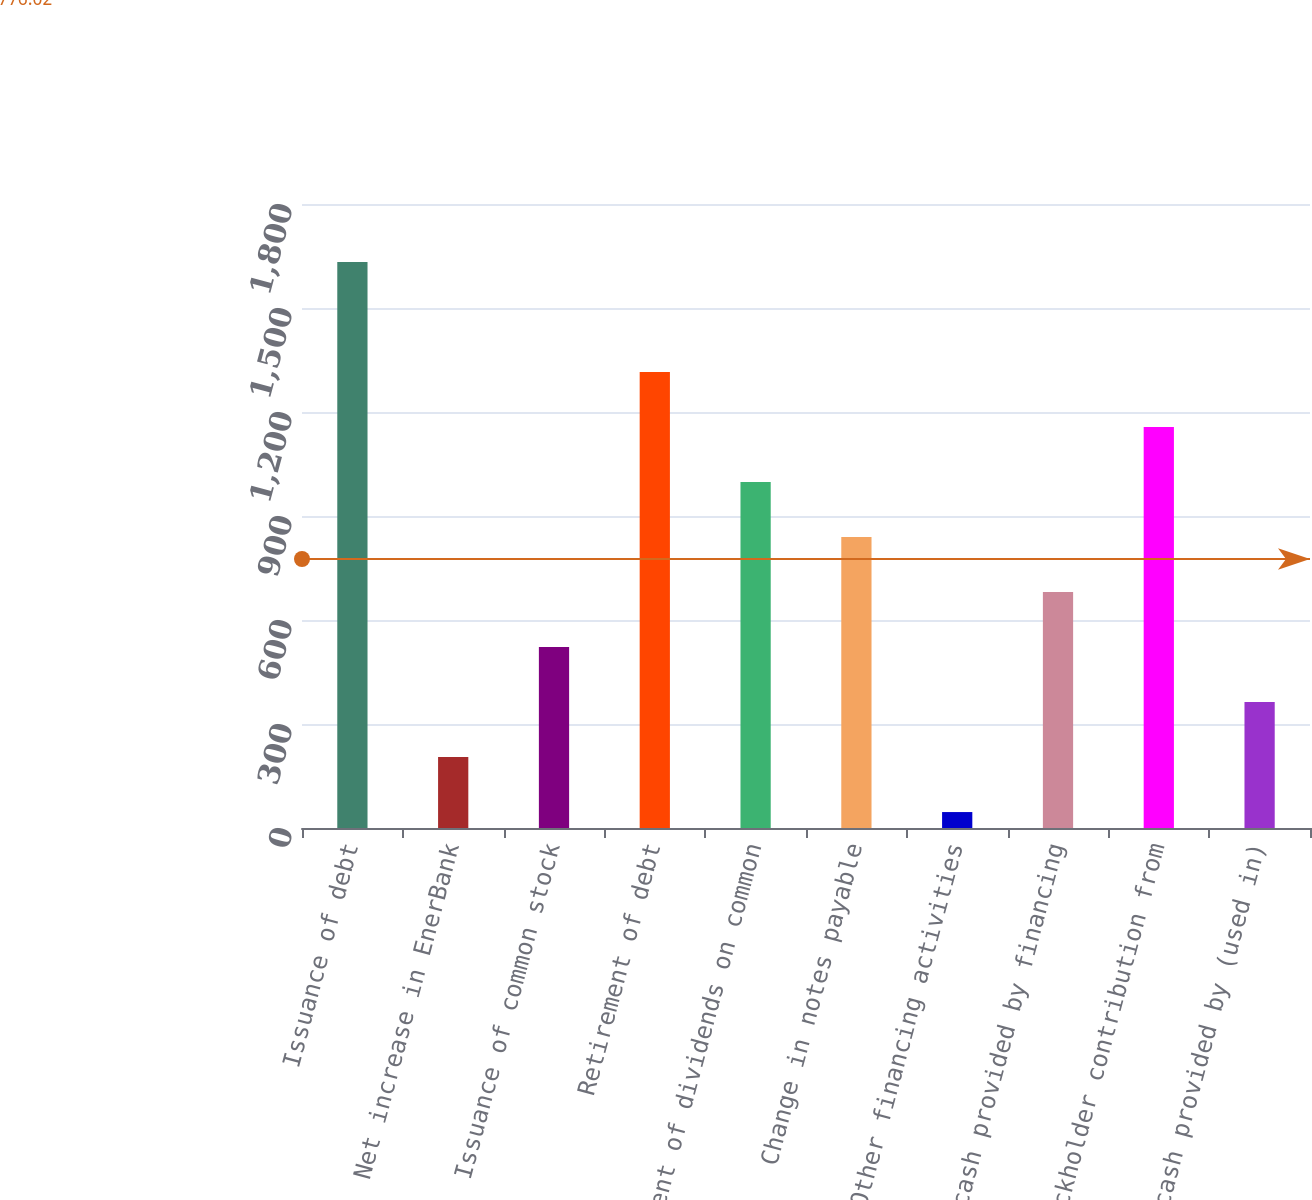<chart> <loc_0><loc_0><loc_500><loc_500><bar_chart><fcel>Issuance of debt<fcel>Net increase in EnerBank<fcel>Issuance of common stock<fcel>Retirement of debt<fcel>Payment of dividends on common<fcel>Change in notes payable<fcel>Other financing activities<fcel>Net cash provided by financing<fcel>Stockholder contribution from<fcel>Net cash provided by (used in)<nl><fcel>1633<fcel>204.7<fcel>522.1<fcel>1315.6<fcel>998.2<fcel>839.5<fcel>46<fcel>680.8<fcel>1156.9<fcel>363.4<nl></chart> 